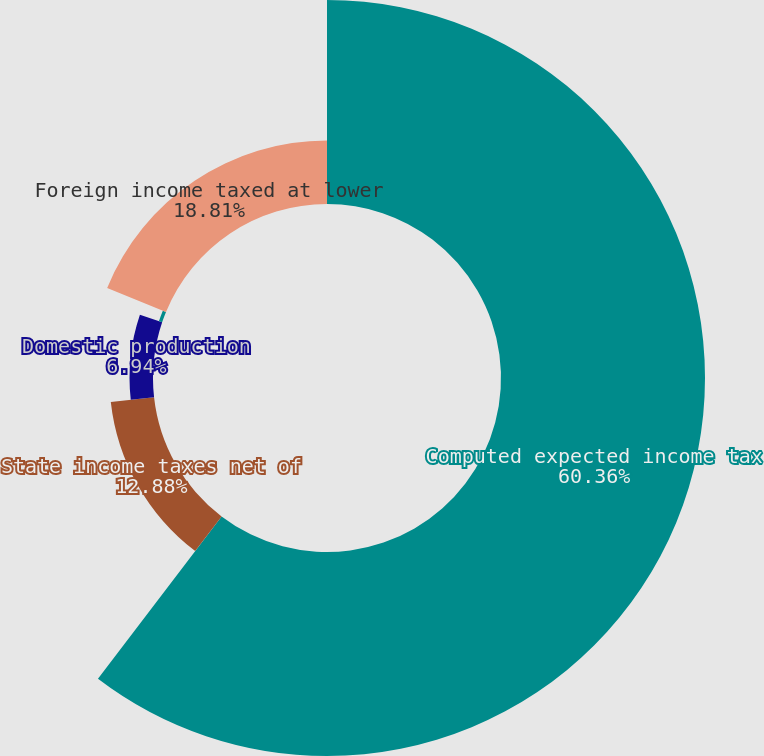<chart> <loc_0><loc_0><loc_500><loc_500><pie_chart><fcel>Computed expected income tax<fcel>State income taxes net of<fcel>Domestic production<fcel>Research and development tax<fcel>Foreign income taxed at lower<nl><fcel>60.36%<fcel>12.88%<fcel>6.94%<fcel>1.01%<fcel>18.81%<nl></chart> 